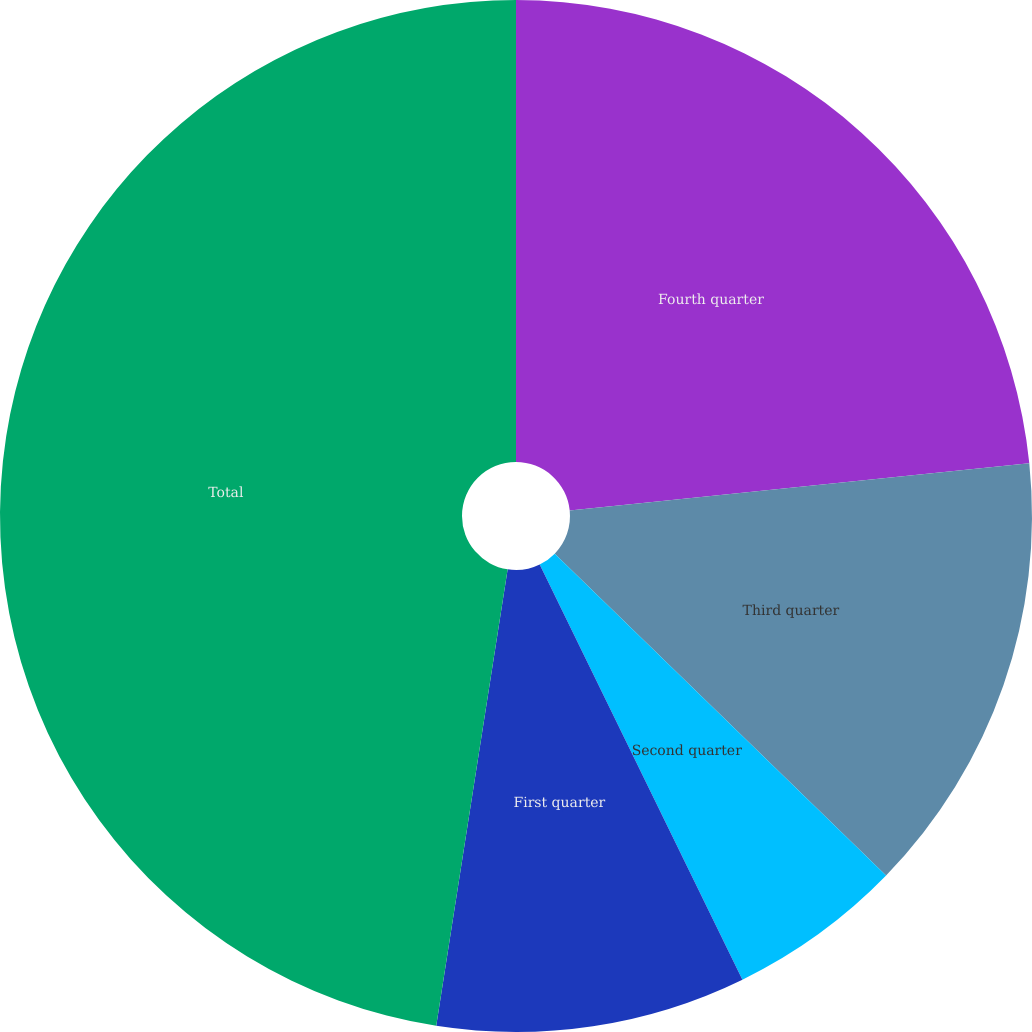Convert chart to OTSL. <chart><loc_0><loc_0><loc_500><loc_500><pie_chart><fcel>Fourth quarter<fcel>Third quarter<fcel>Second quarter<fcel>First quarter<fcel>Total<nl><fcel>23.37%<fcel>13.9%<fcel>5.5%<fcel>9.7%<fcel>47.53%<nl></chart> 